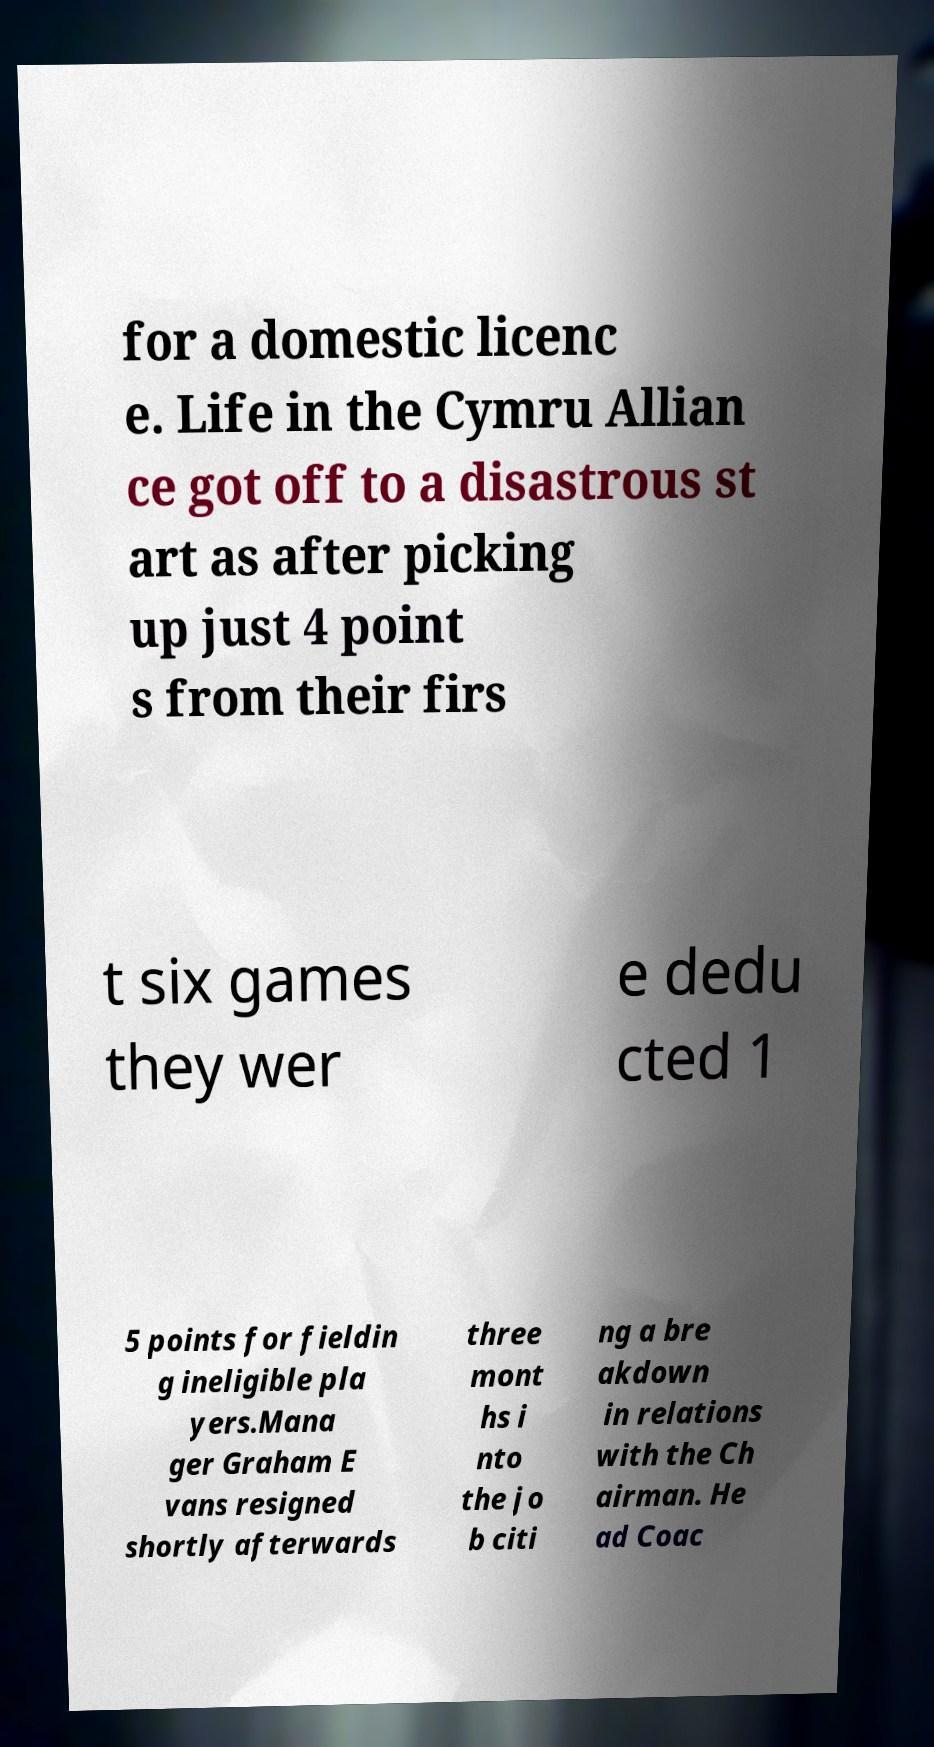Please read and relay the text visible in this image. What does it say? for a domestic licenc e. Life in the Cymru Allian ce got off to a disastrous st art as after picking up just 4 point s from their firs t six games they wer e dedu cted 1 5 points for fieldin g ineligible pla yers.Mana ger Graham E vans resigned shortly afterwards three mont hs i nto the jo b citi ng a bre akdown in relations with the Ch airman. He ad Coac 